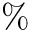Convert formula to latex. <formula><loc_0><loc_0><loc_500><loc_500>\%</formula> 